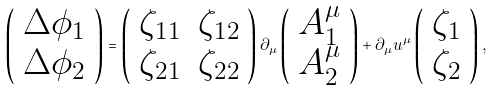Convert formula to latex. <formula><loc_0><loc_0><loc_500><loc_500>\left ( \begin{array} { l } \Delta \phi _ { 1 } \\ \Delta \phi _ { 2 } \end{array} \right ) = \left ( \begin{array} { l l } \zeta _ { 1 1 } & \zeta _ { 1 2 } \\ \zeta _ { 2 1 } & \zeta _ { 2 2 } \end{array} \right ) \partial _ { \mu } \left ( \begin{array} { l } A _ { 1 } ^ { \mu } \\ A _ { 2 } ^ { \mu } \end{array} \right ) + \partial _ { \mu } u ^ { \mu } \left ( \begin{array} { l } \zeta _ { 1 } \\ \zeta _ { 2 } \end{array} \right ) ,</formula> 